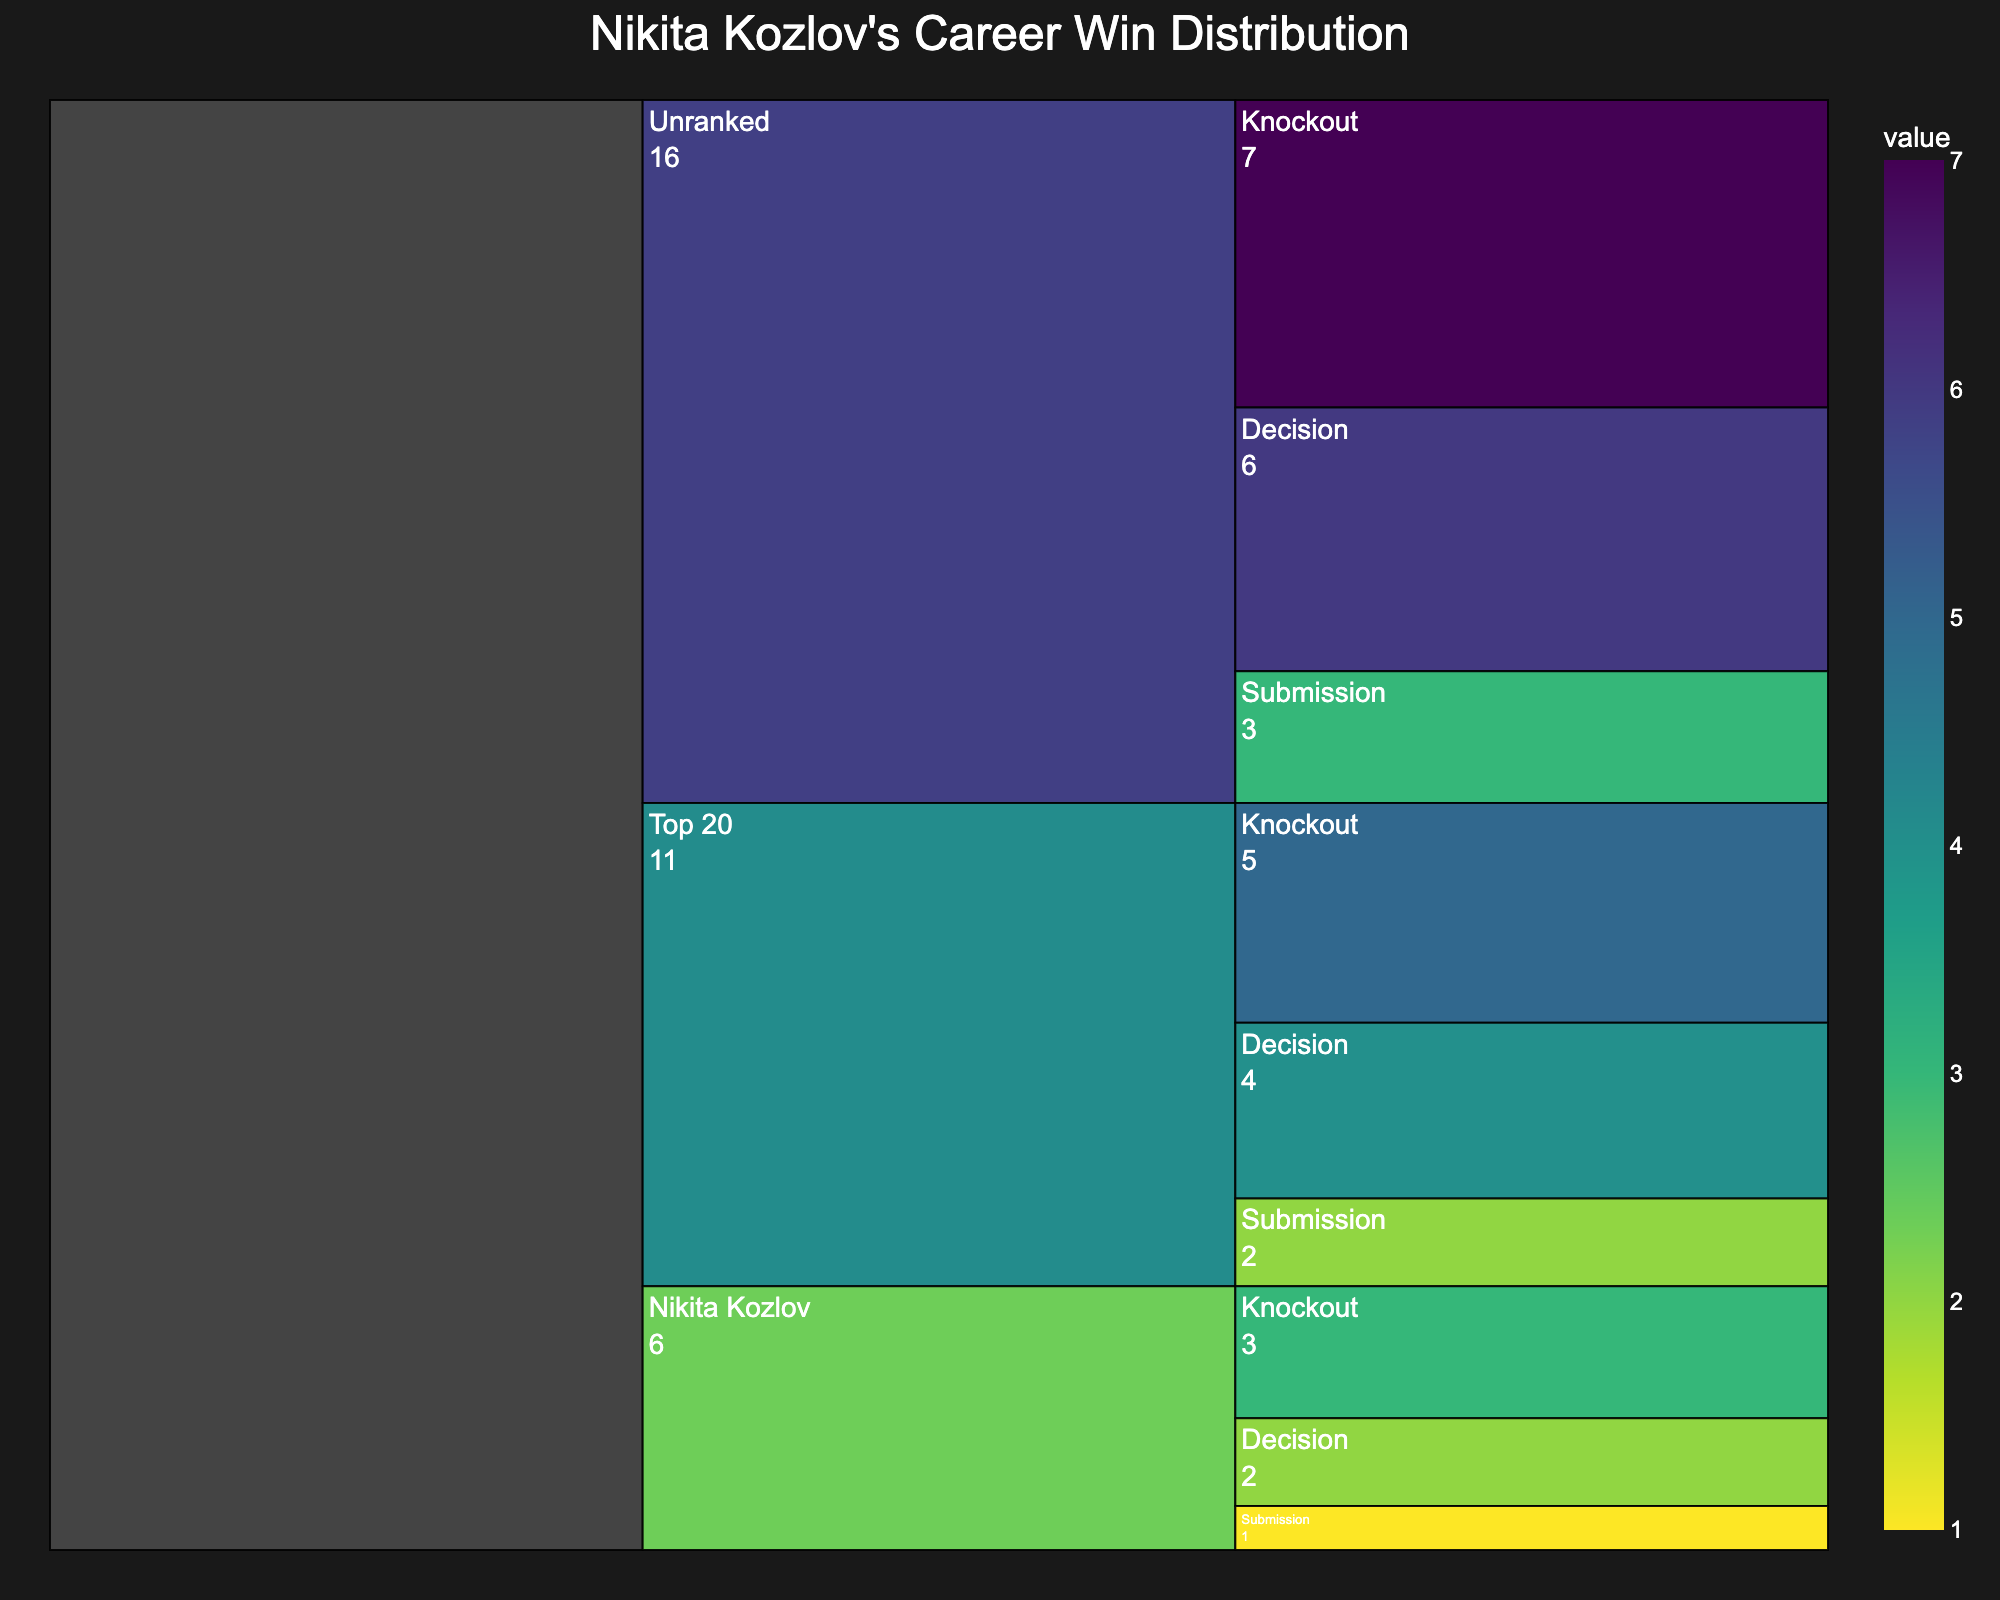What is the title of the Icicle Chart? The title is typically displayed at the top of the chart. In this case, it is clearly stated in the chart's title section.
Answer: Nikita Kozlov's Career Win Distribution What is the total number of wins Nikita Kozlov has against unranked opponents? This involves summing the wins from all methods (Knockout, Decision, Submission) against unranked opponents. The values are 7 (Knockout) + 6 (Decision) + 3 (Submission). The total is 16.
Answer: 16 Which method has the highest number of wins against Top 10 opponents? The Icicle Chart shows the number of wins for each method broken down by opponent ranking. By comparing Knockout (3 wins), Decision (2 wins), and Submission (1 win), Knockout has the highest.
Answer: Knockout How many more wins does Nikita Kozlov have from knockouts compared to submissions overall? Calculate the total wins for knockouts (3 Top 10 + 5 Top 20 + 7 Unranked = 15) and for submissions (1 Top 10 + 2 Top 20 + 3 Unranked = 6). The difference is 15 - 6.
Answer: 9 What is the most common method of victory for Nikita Kozlov? Add up the wins for each method: Knockout (3 + 5 + 7 = 15), Decision (2 + 4 + 6 = 12), and Submission (1 + 2 + 3 = 6). Knockout has the highest total.
Answer: Knockout Which opponent ranking category has the least wins from decisions? Compare the wins from decisions in each ranking category: Top 10 (2), Top 20 (4), and Unranked (6). The least is Top 10.
Answer: Top 10 How does the number of wins by submissions against Top 20 opponents compare to decisions against Top 10 opponents? Compare submissions for Top 20 (2 wins) and decisions for Top 10 (2 wins). They are equal.
Answer: Equal What percentage of Nikita Kozlov's wins are from decisions against unranked opponents? Total wins are 15 (Knockout) + 12 (Decision) + 6 (Submission) = 33. Wins by decisions against unranked opponents are 6. The percentage is (6/33) * 100, which is approximately 18.18%.
Answer: 18.18% Which method contributes the least to Nikita Kozlov's overall wins? Evaluate the totals for each method: Knockout (15), Decision (12), Submission (6). Submission has the least number of wins.
Answer: Submission In which opponent ranking category does Nikita Kozlov have the highest number of wins? Compare the total wins in each ranking category: Top 10 (3 + 2 + 1 = 6), Top 20 (5 + 4 + 2 = 11), and Unranked (7 + 6 + 3 = 16). Unranked has the highest total.
Answer: Unranked 